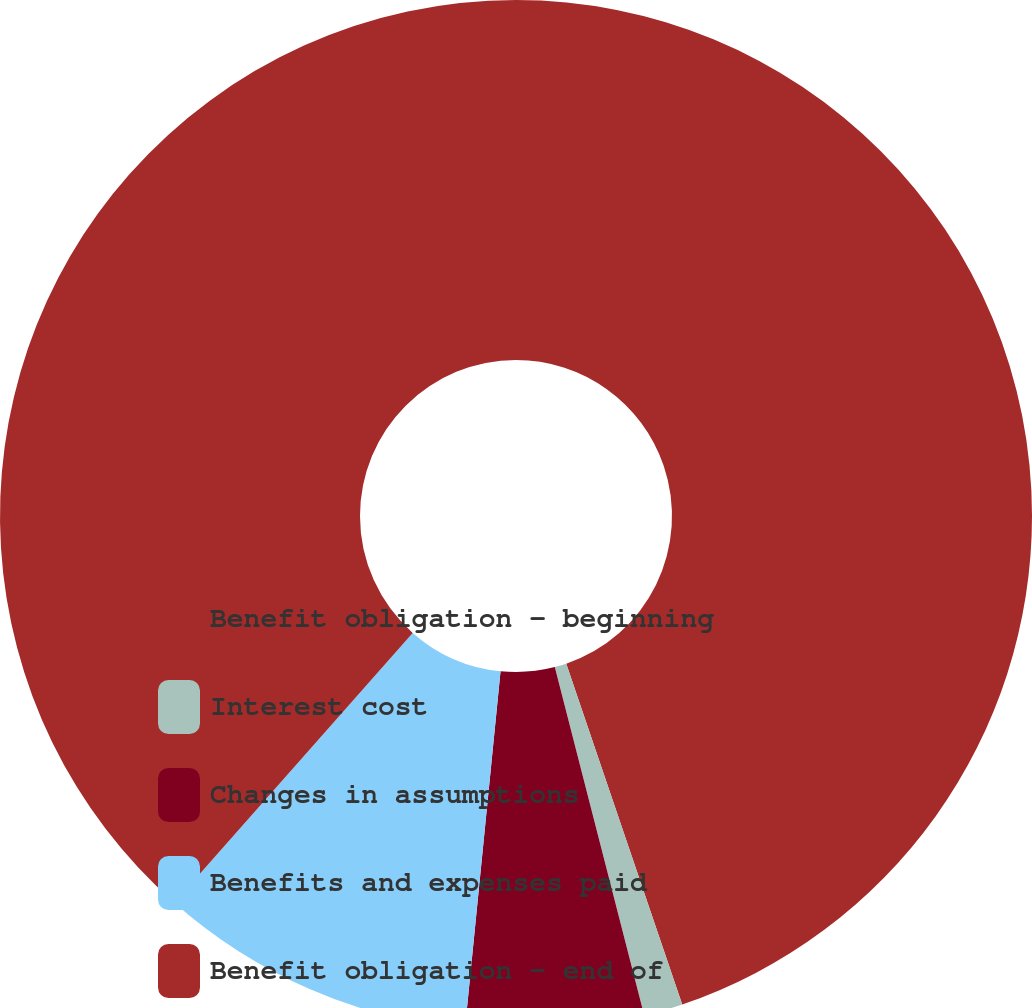<chart> <loc_0><loc_0><loc_500><loc_500><pie_chart><fcel>Benefit obligation - beginning<fcel>Interest cost<fcel>Changes in assumptions<fcel>Benefits and expenses paid<fcel>Benefit obligation - end of<nl><fcel>44.78%<fcel>1.22%<fcel>5.58%<fcel>9.94%<fcel>38.48%<nl></chart> 